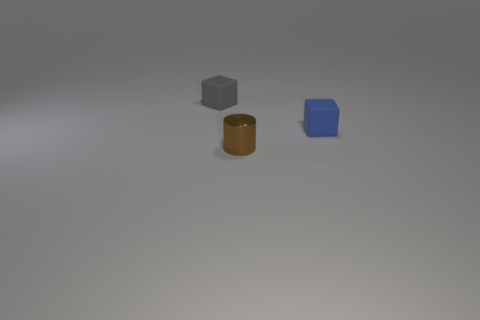Are there any other things that are the same material as the brown cylinder?
Your answer should be compact. No. Does the tiny blue cube have the same material as the small gray object?
Keep it short and to the point. Yes. How many brown things are either cylinders or matte cubes?
Offer a very short reply. 1. How many small blue rubber objects have the same shape as the small gray matte thing?
Ensure brevity in your answer.  1. What is the tiny brown cylinder made of?
Give a very brief answer. Metal. Are there the same number of shiny things left of the tiny brown metallic cylinder and small blue rubber blocks?
Your answer should be compact. No. There is a gray rubber object that is the same size as the blue matte block; what shape is it?
Your response must be concise. Cube. There is a small matte block that is left of the metal cylinder; is there a tiny cube that is on the right side of it?
Your response must be concise. Yes. What number of big objects are either gray rubber cylinders or gray cubes?
Provide a succinct answer. 0. Are there any gray things of the same size as the cylinder?
Provide a succinct answer. Yes. 